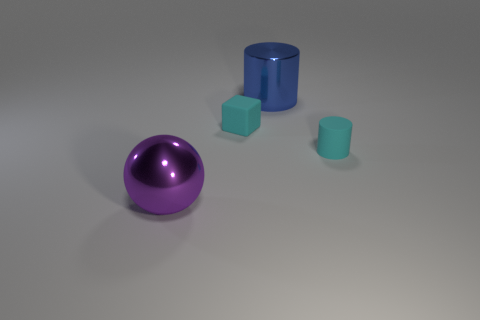The cylinder that is the same size as the cyan rubber block is what color?
Keep it short and to the point. Cyan. Are there an equal number of blue metallic cylinders in front of the blue object and large blue objects on the left side of the purple metal ball?
Provide a succinct answer. Yes. There is a cyan object behind the cyan matte thing right of the big cylinder; what is its material?
Make the answer very short. Rubber. What number of objects are either purple matte cubes or tiny blocks?
Keep it short and to the point. 1. What is the size of the matte cylinder that is the same color as the small cube?
Provide a succinct answer. Small. Is the number of rubber cubes less than the number of brown things?
Offer a very short reply. No. What size is the cylinder that is made of the same material as the ball?
Provide a short and direct response. Large. The sphere is what size?
Your answer should be compact. Large. The large purple thing is what shape?
Ensure brevity in your answer.  Sphere. There is a rubber thing that is left of the tiny cylinder; is its color the same as the tiny cylinder?
Give a very brief answer. Yes. 